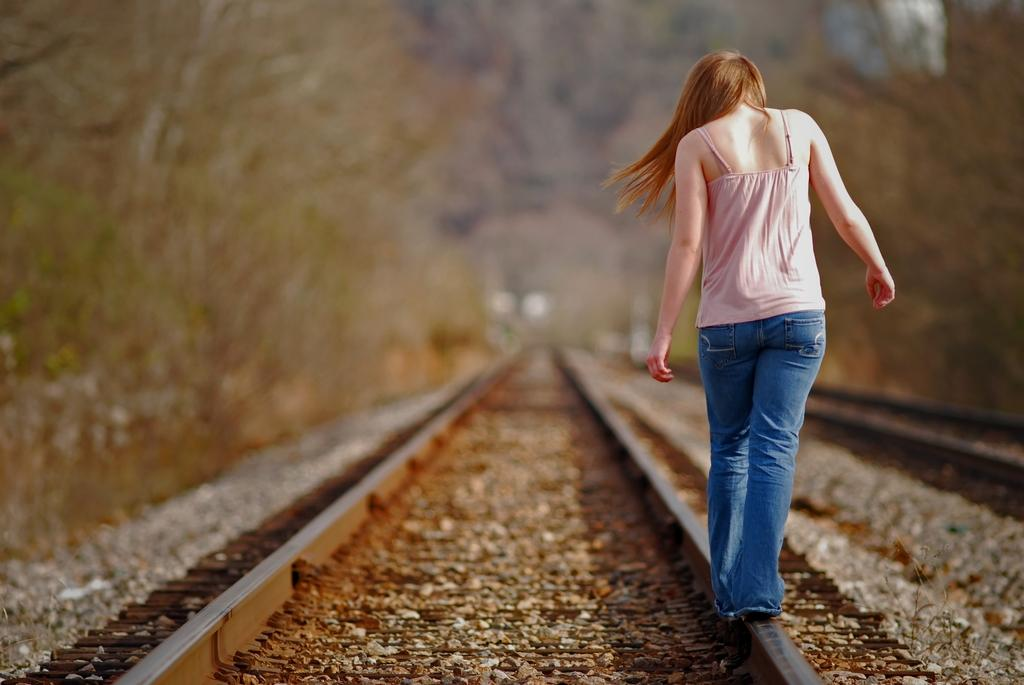What is the main subject of the image? The main subject of the image is a woman. What is the woman doing in the image? The woman is walking on a railway track. Can you describe the background of the image? The background of the image is blurry. Is the woman riding a bike in the image? No, the woman is not riding a bike in the image; she is walking on a railway track. What type of country can be seen in the background of the image? There is no country visible in the background of the image, as the background is blurry. 